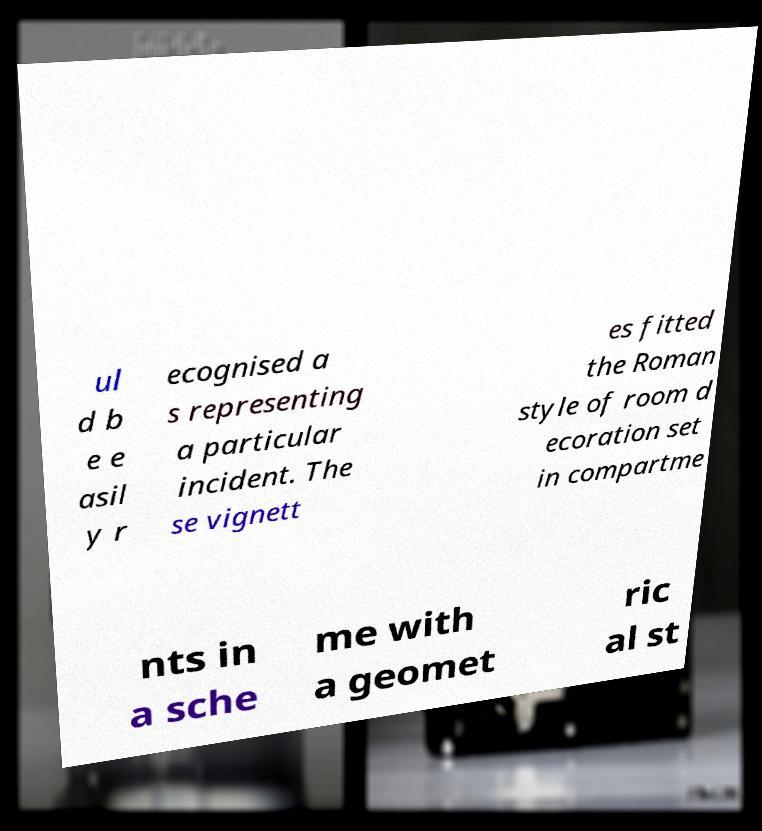Please read and relay the text visible in this image. What does it say? ul d b e e asil y r ecognised a s representing a particular incident. The se vignett es fitted the Roman style of room d ecoration set in compartme nts in a sche me with a geomet ric al st 